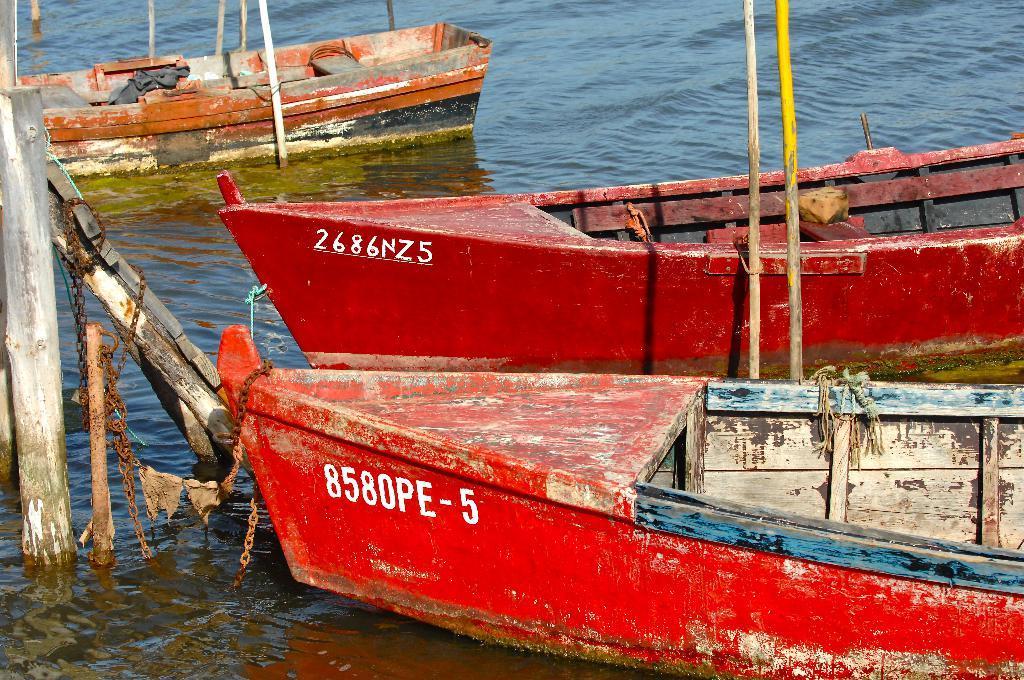Could you give a brief overview of what you see in this image? In this image I can see the water and few boats which are red and orange in color on the surface of the water. I can see few wooden poles and few metal chains. 